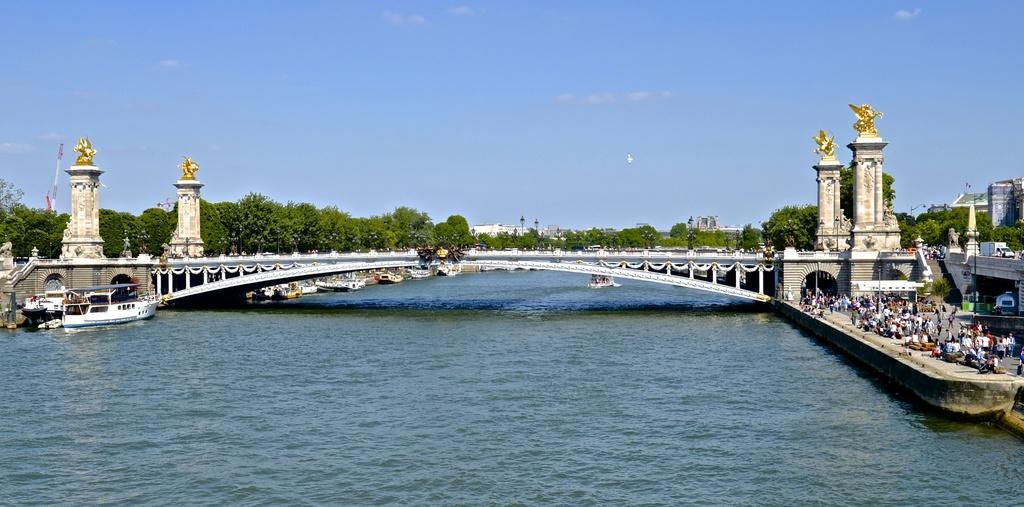Could you give a brief overview of what you see in this image? This is an outside view. At the bottom, I can see the water and there are few boats. In the middle of the image there is a bridge and I can see four pillars on which there are statues. On the right side there are many people on the road and also I can see few buildings. In the background there are many trees. At the top of the image I can see the sky. 